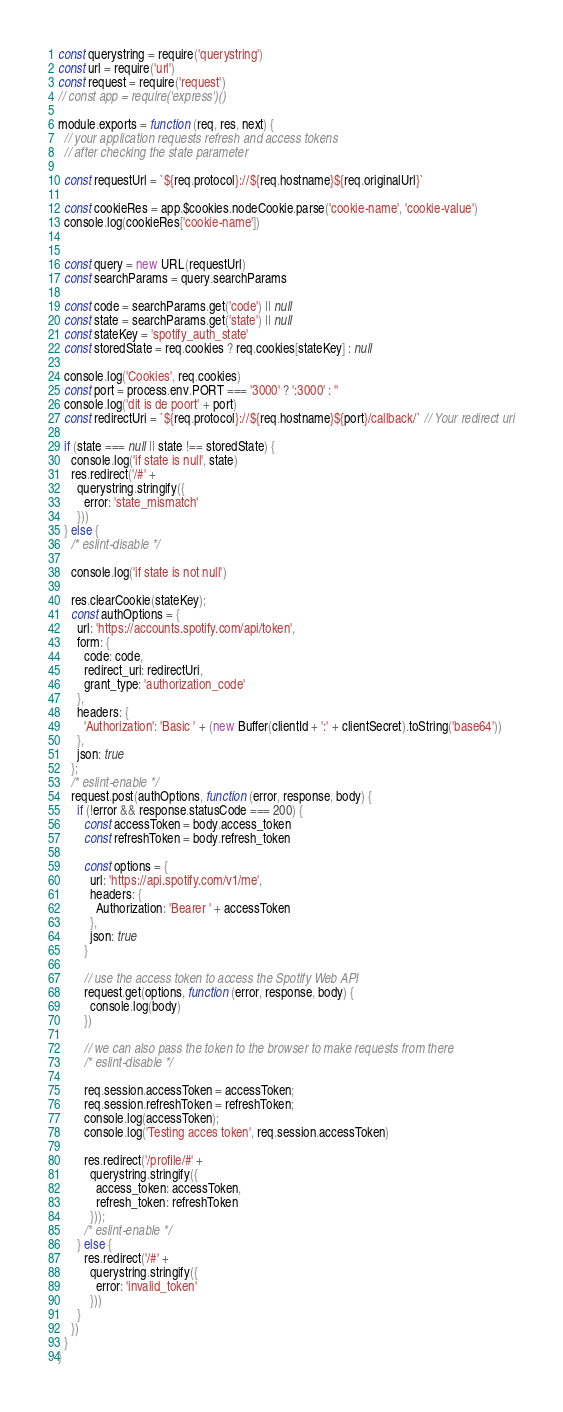<code> <loc_0><loc_0><loc_500><loc_500><_JavaScript_>const querystring = require('querystring')
const url = require('url')
const request = require('request')
// const app = require('express')()

module.exports = function (req, res, next) {
  // your application requests refresh and access tokens
  // after checking the state parameter

  const requestUrl = `${req.protocol}://${req.hostname}${req.originalUrl}`
  
  const cookieRes = app.$cookies.nodeCookie.parse('cookie-name', 'cookie-value')
  console.log(cookieRes['cookie-name'])


  const query = new URL(requestUrl)
  const searchParams = query.searchParams

  const code = searchParams.get('code') || null
  const state = searchParams.get('state') || null
  const stateKey = 'spotify_auth_state'
  const storedState = req.cookies ? req.cookies[stateKey] : null

  console.log('Cookies', req.cookies)
  const port = process.env.PORT === '3000' ? ':3000' : ''
  console.log('dit is de poort' + port)
  const redirectUri = `${req.protocol}://${req.hostname}${port}/callback/` // Your redirect uri

  if (state === null || state !== storedState) {
    console.log('if state is null', state)
    res.redirect('/#' +
      querystring.stringify({
        error: 'state_mismatch'
      }))
  } else {
    /* eslint-disable */

    console.log('if state is not null')

    res.clearCookie(stateKey);
    const authOptions = {
      url: 'https://accounts.spotify.com/api/token',
      form: {
        code: code,
        redirect_uri: redirectUri,
        grant_type: 'authorization_code'
      },
      headers: {
        'Authorization': 'Basic ' + (new Buffer(clientId + ':' + clientSecret).toString('base64'))
      },
      json: true
    };
    /* eslint-enable */
    request.post(authOptions, function (error, response, body) {
      if (!error && response.statusCode === 200) {
        const accessToken = body.access_token
        const refreshToken = body.refresh_token

        const options = {
          url: 'https://api.spotify.com/v1/me',
          headers: {
            Authorization: 'Bearer ' + accessToken
          },
          json: true
        }

        // use the access token to access the Spotify Web API
        request.get(options, function (error, response, body) {
          console.log(body)
        })

        // we can also pass the token to the browser to make requests from there
        /* eslint-disable */

        req.session.accessToken = accessToken;
        req.session.refreshToken = refreshToken;
        console.log(accessToken);
        console.log('Testing acces token', req.session.accessToken)

        res.redirect('/profile/#' +
          querystring.stringify({
            access_token: accessToken,
            refresh_token: refreshToken
          }));
        /* eslint-enable */
      } else {
        res.redirect('/#' +
          querystring.stringify({
            error: 'invalid_token'
          }))
      }
    })
  }
}
</code> 